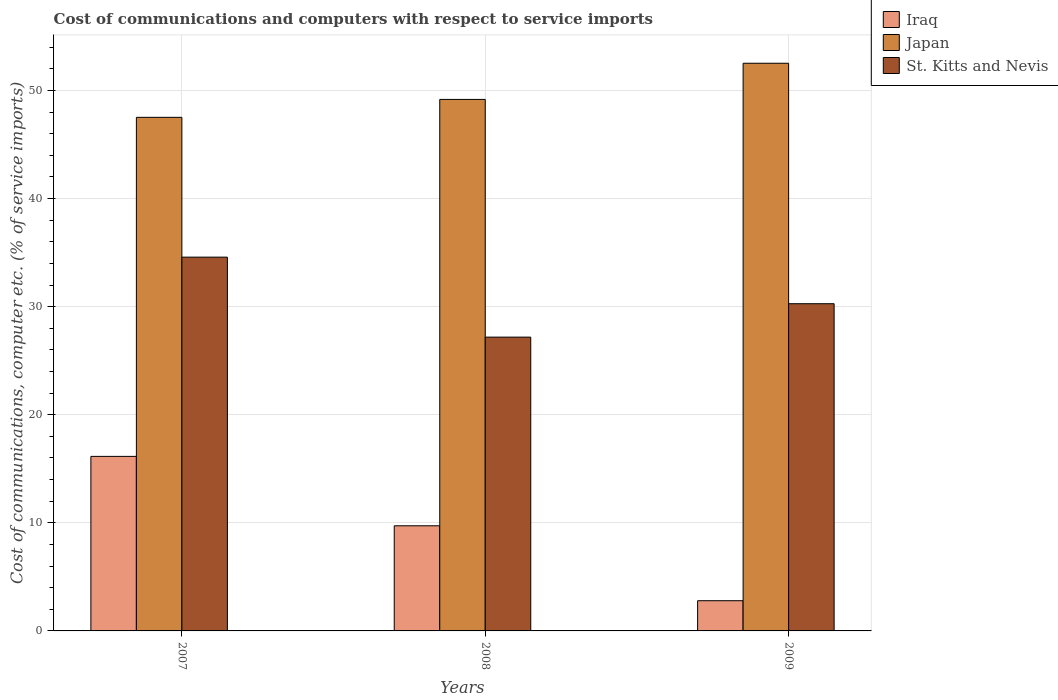Are the number of bars per tick equal to the number of legend labels?
Your answer should be compact. Yes. How many bars are there on the 2nd tick from the left?
Provide a short and direct response. 3. What is the label of the 1st group of bars from the left?
Keep it short and to the point. 2007. In how many cases, is the number of bars for a given year not equal to the number of legend labels?
Give a very brief answer. 0. What is the cost of communications and computers in Iraq in 2007?
Offer a terse response. 16.15. Across all years, what is the maximum cost of communications and computers in St. Kitts and Nevis?
Make the answer very short. 34.58. Across all years, what is the minimum cost of communications and computers in St. Kitts and Nevis?
Your answer should be very brief. 27.18. What is the total cost of communications and computers in Iraq in the graph?
Give a very brief answer. 28.67. What is the difference between the cost of communications and computers in Iraq in 2007 and that in 2008?
Your answer should be compact. 6.42. What is the difference between the cost of communications and computers in Japan in 2008 and the cost of communications and computers in Iraq in 2007?
Your response must be concise. 33.03. What is the average cost of communications and computers in Iraq per year?
Keep it short and to the point. 9.56. In the year 2007, what is the difference between the cost of communications and computers in St. Kitts and Nevis and cost of communications and computers in Japan?
Make the answer very short. -12.94. In how many years, is the cost of communications and computers in St. Kitts and Nevis greater than 44 %?
Keep it short and to the point. 0. What is the ratio of the cost of communications and computers in Japan in 2007 to that in 2009?
Offer a very short reply. 0.9. Is the difference between the cost of communications and computers in St. Kitts and Nevis in 2007 and 2009 greater than the difference between the cost of communications and computers in Japan in 2007 and 2009?
Ensure brevity in your answer.  Yes. What is the difference between the highest and the second highest cost of communications and computers in Japan?
Provide a short and direct response. 3.34. What is the difference between the highest and the lowest cost of communications and computers in Japan?
Offer a very short reply. 5. In how many years, is the cost of communications and computers in Iraq greater than the average cost of communications and computers in Iraq taken over all years?
Your response must be concise. 2. Is the sum of the cost of communications and computers in St. Kitts and Nevis in 2007 and 2009 greater than the maximum cost of communications and computers in Iraq across all years?
Your response must be concise. Yes. What does the 3rd bar from the left in 2008 represents?
Provide a succinct answer. St. Kitts and Nevis. What does the 1st bar from the right in 2008 represents?
Offer a terse response. St. Kitts and Nevis. How many bars are there?
Your answer should be compact. 9. What is the difference between two consecutive major ticks on the Y-axis?
Your answer should be compact. 10. Does the graph contain any zero values?
Provide a succinct answer. No. Does the graph contain grids?
Your response must be concise. Yes. What is the title of the graph?
Your answer should be compact. Cost of communications and computers with respect to service imports. What is the label or title of the Y-axis?
Give a very brief answer. Cost of communications, computer etc. (% of service imports). What is the Cost of communications, computer etc. (% of service imports) of Iraq in 2007?
Offer a terse response. 16.15. What is the Cost of communications, computer etc. (% of service imports) in Japan in 2007?
Ensure brevity in your answer.  47.52. What is the Cost of communications, computer etc. (% of service imports) of St. Kitts and Nevis in 2007?
Keep it short and to the point. 34.58. What is the Cost of communications, computer etc. (% of service imports) of Iraq in 2008?
Your answer should be compact. 9.73. What is the Cost of communications, computer etc. (% of service imports) of Japan in 2008?
Your response must be concise. 49.18. What is the Cost of communications, computer etc. (% of service imports) in St. Kitts and Nevis in 2008?
Give a very brief answer. 27.18. What is the Cost of communications, computer etc. (% of service imports) of Iraq in 2009?
Offer a very short reply. 2.79. What is the Cost of communications, computer etc. (% of service imports) of Japan in 2009?
Provide a short and direct response. 52.52. What is the Cost of communications, computer etc. (% of service imports) of St. Kitts and Nevis in 2009?
Give a very brief answer. 30.27. Across all years, what is the maximum Cost of communications, computer etc. (% of service imports) in Iraq?
Your answer should be compact. 16.15. Across all years, what is the maximum Cost of communications, computer etc. (% of service imports) in Japan?
Make the answer very short. 52.52. Across all years, what is the maximum Cost of communications, computer etc. (% of service imports) in St. Kitts and Nevis?
Offer a very short reply. 34.58. Across all years, what is the minimum Cost of communications, computer etc. (% of service imports) of Iraq?
Offer a terse response. 2.79. Across all years, what is the minimum Cost of communications, computer etc. (% of service imports) of Japan?
Provide a short and direct response. 47.52. Across all years, what is the minimum Cost of communications, computer etc. (% of service imports) of St. Kitts and Nevis?
Provide a succinct answer. 27.18. What is the total Cost of communications, computer etc. (% of service imports) in Iraq in the graph?
Offer a very short reply. 28.67. What is the total Cost of communications, computer etc. (% of service imports) in Japan in the graph?
Your answer should be very brief. 149.22. What is the total Cost of communications, computer etc. (% of service imports) in St. Kitts and Nevis in the graph?
Your response must be concise. 92.04. What is the difference between the Cost of communications, computer etc. (% of service imports) of Iraq in 2007 and that in 2008?
Your answer should be compact. 6.42. What is the difference between the Cost of communications, computer etc. (% of service imports) in Japan in 2007 and that in 2008?
Make the answer very short. -1.66. What is the difference between the Cost of communications, computer etc. (% of service imports) in St. Kitts and Nevis in 2007 and that in 2008?
Offer a very short reply. 7.4. What is the difference between the Cost of communications, computer etc. (% of service imports) in Iraq in 2007 and that in 2009?
Provide a succinct answer. 13.35. What is the difference between the Cost of communications, computer etc. (% of service imports) of Japan in 2007 and that in 2009?
Make the answer very short. -5. What is the difference between the Cost of communications, computer etc. (% of service imports) of St. Kitts and Nevis in 2007 and that in 2009?
Offer a very short reply. 4.31. What is the difference between the Cost of communications, computer etc. (% of service imports) of Iraq in 2008 and that in 2009?
Provide a short and direct response. 6.93. What is the difference between the Cost of communications, computer etc. (% of service imports) of Japan in 2008 and that in 2009?
Give a very brief answer. -3.34. What is the difference between the Cost of communications, computer etc. (% of service imports) in St. Kitts and Nevis in 2008 and that in 2009?
Offer a very short reply. -3.09. What is the difference between the Cost of communications, computer etc. (% of service imports) in Iraq in 2007 and the Cost of communications, computer etc. (% of service imports) in Japan in 2008?
Give a very brief answer. -33.03. What is the difference between the Cost of communications, computer etc. (% of service imports) of Iraq in 2007 and the Cost of communications, computer etc. (% of service imports) of St. Kitts and Nevis in 2008?
Your response must be concise. -11.03. What is the difference between the Cost of communications, computer etc. (% of service imports) in Japan in 2007 and the Cost of communications, computer etc. (% of service imports) in St. Kitts and Nevis in 2008?
Make the answer very short. 20.34. What is the difference between the Cost of communications, computer etc. (% of service imports) of Iraq in 2007 and the Cost of communications, computer etc. (% of service imports) of Japan in 2009?
Keep it short and to the point. -36.37. What is the difference between the Cost of communications, computer etc. (% of service imports) in Iraq in 2007 and the Cost of communications, computer etc. (% of service imports) in St. Kitts and Nevis in 2009?
Ensure brevity in your answer.  -14.13. What is the difference between the Cost of communications, computer etc. (% of service imports) of Japan in 2007 and the Cost of communications, computer etc. (% of service imports) of St. Kitts and Nevis in 2009?
Make the answer very short. 17.24. What is the difference between the Cost of communications, computer etc. (% of service imports) of Iraq in 2008 and the Cost of communications, computer etc. (% of service imports) of Japan in 2009?
Offer a terse response. -42.79. What is the difference between the Cost of communications, computer etc. (% of service imports) in Iraq in 2008 and the Cost of communications, computer etc. (% of service imports) in St. Kitts and Nevis in 2009?
Ensure brevity in your answer.  -20.55. What is the difference between the Cost of communications, computer etc. (% of service imports) of Japan in 2008 and the Cost of communications, computer etc. (% of service imports) of St. Kitts and Nevis in 2009?
Give a very brief answer. 18.9. What is the average Cost of communications, computer etc. (% of service imports) of Iraq per year?
Ensure brevity in your answer.  9.56. What is the average Cost of communications, computer etc. (% of service imports) of Japan per year?
Ensure brevity in your answer.  49.74. What is the average Cost of communications, computer etc. (% of service imports) in St. Kitts and Nevis per year?
Ensure brevity in your answer.  30.68. In the year 2007, what is the difference between the Cost of communications, computer etc. (% of service imports) of Iraq and Cost of communications, computer etc. (% of service imports) of Japan?
Your answer should be compact. -31.37. In the year 2007, what is the difference between the Cost of communications, computer etc. (% of service imports) in Iraq and Cost of communications, computer etc. (% of service imports) in St. Kitts and Nevis?
Ensure brevity in your answer.  -18.43. In the year 2007, what is the difference between the Cost of communications, computer etc. (% of service imports) of Japan and Cost of communications, computer etc. (% of service imports) of St. Kitts and Nevis?
Offer a very short reply. 12.94. In the year 2008, what is the difference between the Cost of communications, computer etc. (% of service imports) in Iraq and Cost of communications, computer etc. (% of service imports) in Japan?
Give a very brief answer. -39.45. In the year 2008, what is the difference between the Cost of communications, computer etc. (% of service imports) of Iraq and Cost of communications, computer etc. (% of service imports) of St. Kitts and Nevis?
Your answer should be very brief. -17.46. In the year 2008, what is the difference between the Cost of communications, computer etc. (% of service imports) in Japan and Cost of communications, computer etc. (% of service imports) in St. Kitts and Nevis?
Give a very brief answer. 21.99. In the year 2009, what is the difference between the Cost of communications, computer etc. (% of service imports) of Iraq and Cost of communications, computer etc. (% of service imports) of Japan?
Ensure brevity in your answer.  -49.73. In the year 2009, what is the difference between the Cost of communications, computer etc. (% of service imports) of Iraq and Cost of communications, computer etc. (% of service imports) of St. Kitts and Nevis?
Your answer should be very brief. -27.48. In the year 2009, what is the difference between the Cost of communications, computer etc. (% of service imports) of Japan and Cost of communications, computer etc. (% of service imports) of St. Kitts and Nevis?
Your response must be concise. 22.25. What is the ratio of the Cost of communications, computer etc. (% of service imports) in Iraq in 2007 to that in 2008?
Offer a very short reply. 1.66. What is the ratio of the Cost of communications, computer etc. (% of service imports) of Japan in 2007 to that in 2008?
Keep it short and to the point. 0.97. What is the ratio of the Cost of communications, computer etc. (% of service imports) in St. Kitts and Nevis in 2007 to that in 2008?
Provide a short and direct response. 1.27. What is the ratio of the Cost of communications, computer etc. (% of service imports) of Iraq in 2007 to that in 2009?
Offer a terse response. 5.78. What is the ratio of the Cost of communications, computer etc. (% of service imports) of Japan in 2007 to that in 2009?
Offer a terse response. 0.9. What is the ratio of the Cost of communications, computer etc. (% of service imports) of St. Kitts and Nevis in 2007 to that in 2009?
Offer a very short reply. 1.14. What is the ratio of the Cost of communications, computer etc. (% of service imports) of Iraq in 2008 to that in 2009?
Make the answer very short. 3.48. What is the ratio of the Cost of communications, computer etc. (% of service imports) in Japan in 2008 to that in 2009?
Your response must be concise. 0.94. What is the ratio of the Cost of communications, computer etc. (% of service imports) in St. Kitts and Nevis in 2008 to that in 2009?
Offer a very short reply. 0.9. What is the difference between the highest and the second highest Cost of communications, computer etc. (% of service imports) in Iraq?
Provide a short and direct response. 6.42. What is the difference between the highest and the second highest Cost of communications, computer etc. (% of service imports) of Japan?
Provide a short and direct response. 3.34. What is the difference between the highest and the second highest Cost of communications, computer etc. (% of service imports) in St. Kitts and Nevis?
Your answer should be compact. 4.31. What is the difference between the highest and the lowest Cost of communications, computer etc. (% of service imports) in Iraq?
Provide a short and direct response. 13.35. What is the difference between the highest and the lowest Cost of communications, computer etc. (% of service imports) of Japan?
Provide a short and direct response. 5. What is the difference between the highest and the lowest Cost of communications, computer etc. (% of service imports) of St. Kitts and Nevis?
Your answer should be compact. 7.4. 